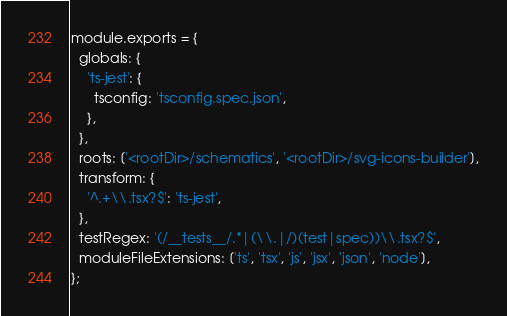Convert code to text. <code><loc_0><loc_0><loc_500><loc_500><_JavaScript_>module.exports = {
  globals: {
    'ts-jest': {
      tsconfig: 'tsconfig.spec.json',
    },
  },
  roots: ['<rootDir>/schematics', '<rootDir>/svg-icons-builder'],
  transform: {
    '^.+\\.tsx?$': 'ts-jest',
  },
  testRegex: '(/__tests__/.*|(\\.|/)(test|spec))\\.tsx?$',
  moduleFileExtensions: ['ts', 'tsx', 'js', 'jsx', 'json', 'node'],
};
</code> 